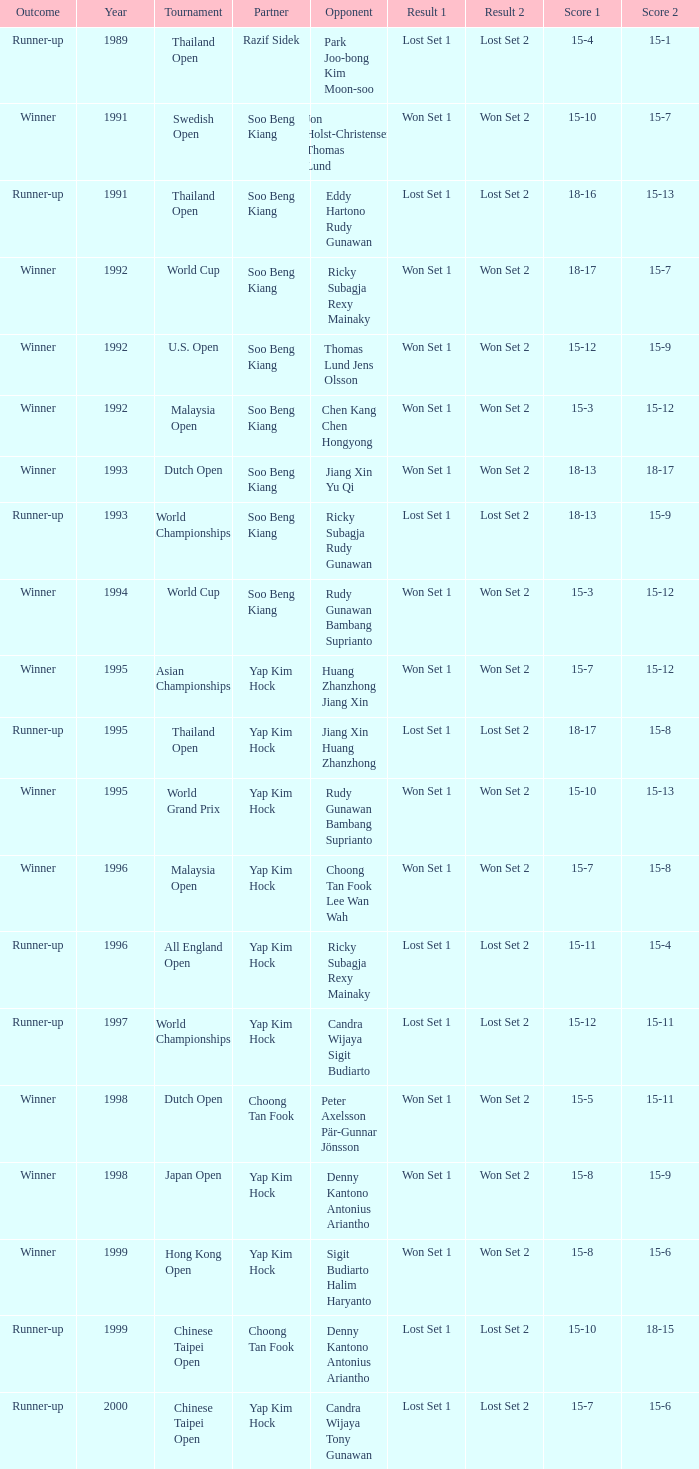Which opponent played in the Chinese Taipei Open in 2000? Candra Wijaya Tony Gunawan. 